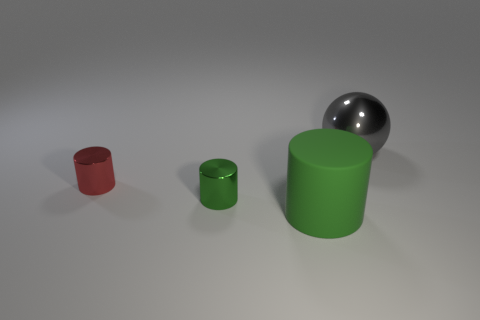Add 2 yellow matte things. How many objects exist? 6 Subtract all spheres. How many objects are left? 3 Add 3 big gray things. How many big gray things are left? 4 Add 3 brown matte cubes. How many brown matte cubes exist? 3 Subtract 0 purple balls. How many objects are left? 4 Subtract all large rubber things. Subtract all big balls. How many objects are left? 2 